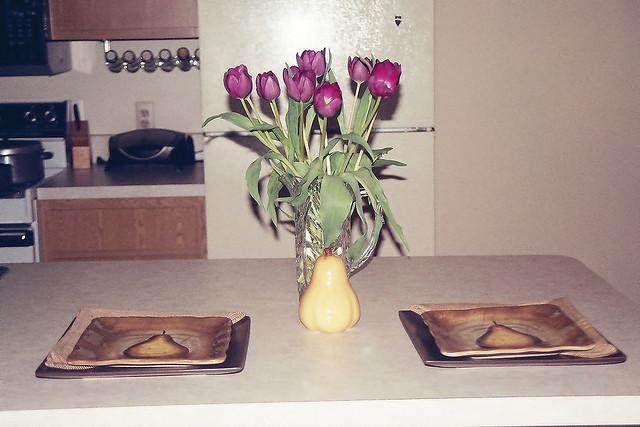What rooms are the flowers in?
Give a very brief answer. Kitchen. How many places are set?
Short answer required. 2. How many flowers are in the vase?
Keep it brief. 7. What is painted on the plates?
Write a very short answer. Pear. 